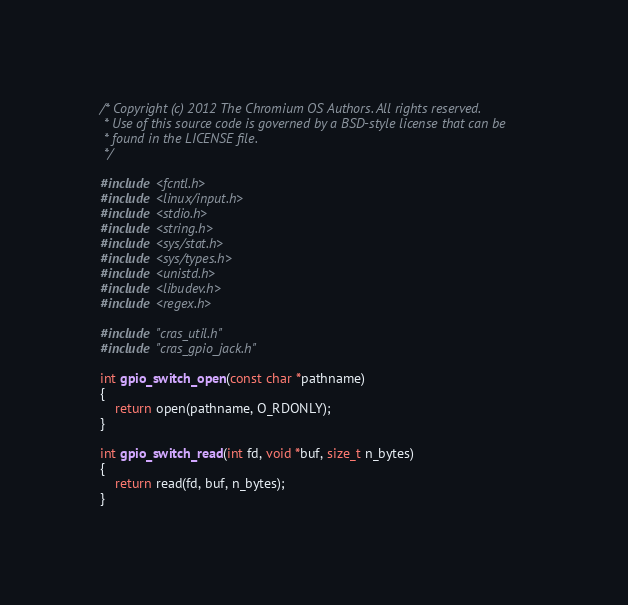<code> <loc_0><loc_0><loc_500><loc_500><_C_>/* Copyright (c) 2012 The Chromium OS Authors. All rights reserved.
 * Use of this source code is governed by a BSD-style license that can be
 * found in the LICENSE file.
 */

#include <fcntl.h>
#include <linux/input.h>
#include <stdio.h>
#include <string.h>
#include <sys/stat.h>
#include <sys/types.h>
#include <unistd.h>
#include <libudev.h>
#include <regex.h>

#include "cras_util.h"
#include "cras_gpio_jack.h"

int gpio_switch_open(const char *pathname)
{
	return open(pathname, O_RDONLY);
}

int gpio_switch_read(int fd, void *buf, size_t n_bytes)
{
	return read(fd, buf, n_bytes);
}
</code> 